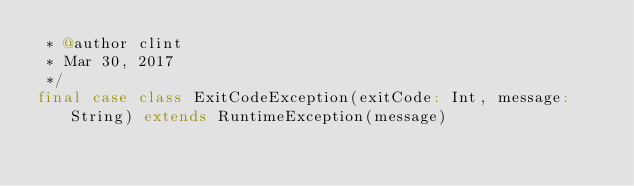<code> <loc_0><loc_0><loc_500><loc_500><_Scala_> * @author clint
 * Mar 30, 2017
 */
final case class ExitCodeException(exitCode: Int, message: String) extends RuntimeException(message)
</code> 